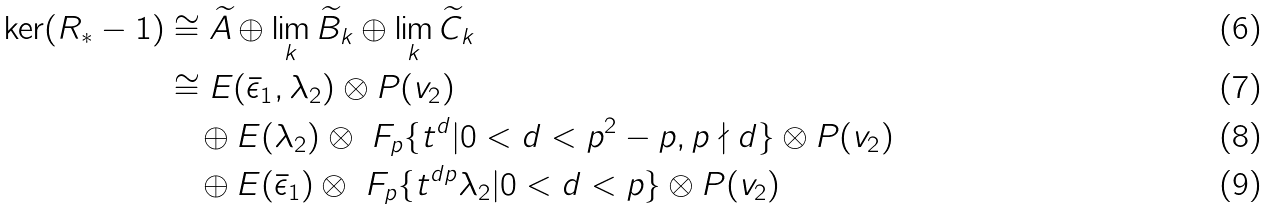<formula> <loc_0><loc_0><loc_500><loc_500>\ker ( R _ { * } - 1 ) & \cong \widetilde { A } \oplus \lim _ { k } \widetilde { B } _ { k } \oplus \lim _ { k } \widetilde { C } _ { k } \\ & \cong E ( \bar { \epsilon } _ { 1 } , \lambda _ { 2 } ) \otimes P ( v _ { 2 } ) \\ & \quad \oplus E ( \lambda _ { 2 } ) \otimes \ F _ { p } \{ t ^ { d } | 0 < d < p ^ { 2 } - p , p \nmid d \} \otimes P ( v _ { 2 } ) \\ & \quad \oplus E ( \bar { \epsilon } _ { 1 } ) \otimes \ F _ { p } \{ t ^ { d p } \lambda _ { 2 } | 0 < d < p \} \otimes P ( v _ { 2 } )</formula> 